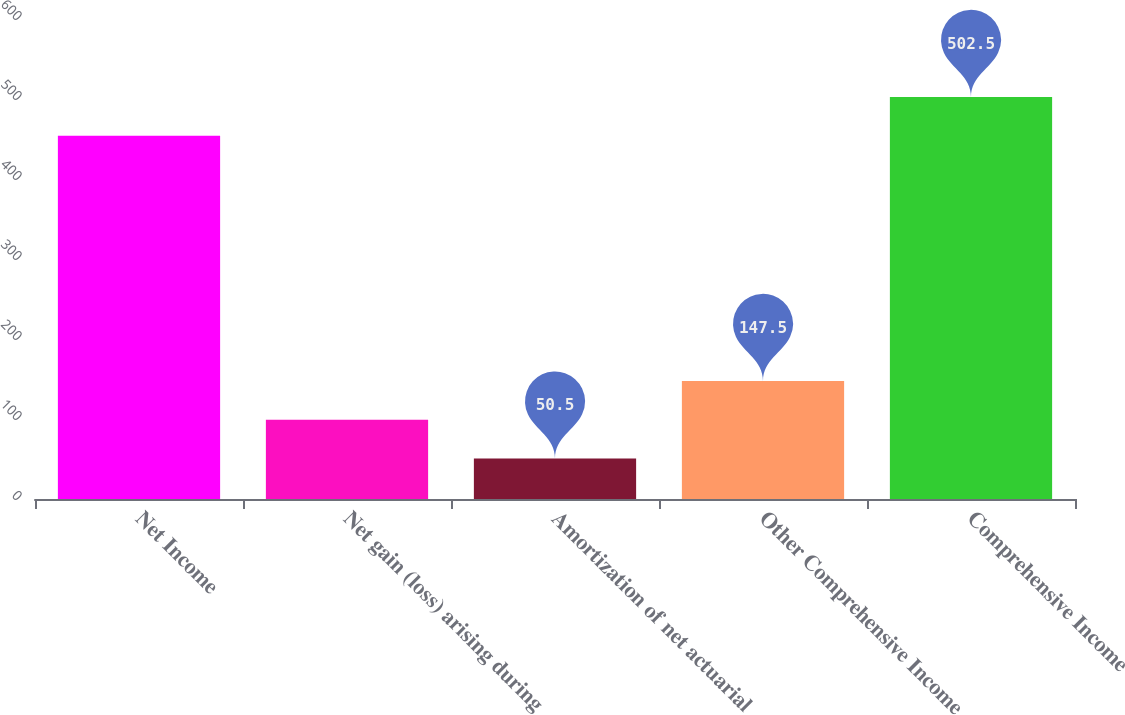<chart> <loc_0><loc_0><loc_500><loc_500><bar_chart><fcel>Net Income<fcel>Net gain (loss) arising during<fcel>Amortization of net actuarial<fcel>Other Comprehensive Income<fcel>Comprehensive Income<nl><fcel>454<fcel>99<fcel>50.5<fcel>147.5<fcel>502.5<nl></chart> 